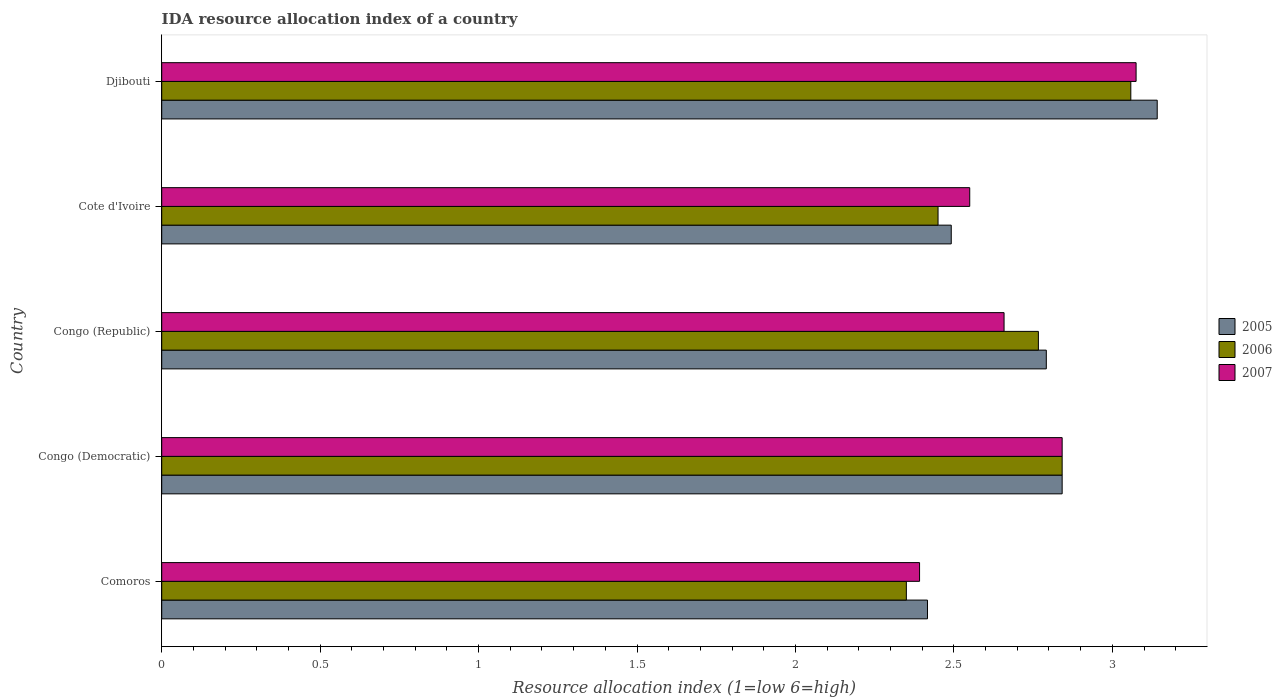How many groups of bars are there?
Your answer should be very brief. 5. Are the number of bars per tick equal to the number of legend labels?
Offer a very short reply. Yes. How many bars are there on the 3rd tick from the top?
Provide a succinct answer. 3. What is the label of the 1st group of bars from the top?
Your answer should be compact. Djibouti. What is the IDA resource allocation index in 2006 in Congo (Republic)?
Provide a succinct answer. 2.77. Across all countries, what is the maximum IDA resource allocation index in 2006?
Make the answer very short. 3.06. Across all countries, what is the minimum IDA resource allocation index in 2005?
Your response must be concise. 2.42. In which country was the IDA resource allocation index in 2007 maximum?
Your answer should be very brief. Djibouti. In which country was the IDA resource allocation index in 2007 minimum?
Give a very brief answer. Comoros. What is the total IDA resource allocation index in 2005 in the graph?
Make the answer very short. 13.68. What is the difference between the IDA resource allocation index in 2006 in Comoros and that in Congo (Democratic)?
Offer a terse response. -0.49. What is the difference between the IDA resource allocation index in 2007 in Djibouti and the IDA resource allocation index in 2005 in Cote d'Ivoire?
Make the answer very short. 0.58. What is the average IDA resource allocation index in 2005 per country?
Offer a very short reply. 2.74. What is the difference between the IDA resource allocation index in 2005 and IDA resource allocation index in 2006 in Cote d'Ivoire?
Give a very brief answer. 0.04. In how many countries, is the IDA resource allocation index in 2006 greater than 2.5 ?
Ensure brevity in your answer.  3. What is the ratio of the IDA resource allocation index in 2007 in Comoros to that in Djibouti?
Your answer should be very brief. 0.78. Is the IDA resource allocation index in 2006 in Comoros less than that in Congo (Republic)?
Provide a succinct answer. Yes. What is the difference between the highest and the second highest IDA resource allocation index in 2007?
Offer a terse response. 0.23. What is the difference between the highest and the lowest IDA resource allocation index in 2006?
Keep it short and to the point. 0.71. Is the sum of the IDA resource allocation index in 2006 in Congo (Republic) and Cote d'Ivoire greater than the maximum IDA resource allocation index in 2005 across all countries?
Provide a succinct answer. Yes. Are all the bars in the graph horizontal?
Offer a very short reply. Yes. How many countries are there in the graph?
Ensure brevity in your answer.  5. Where does the legend appear in the graph?
Keep it short and to the point. Center right. How many legend labels are there?
Offer a very short reply. 3. How are the legend labels stacked?
Your response must be concise. Vertical. What is the title of the graph?
Keep it short and to the point. IDA resource allocation index of a country. What is the label or title of the X-axis?
Give a very brief answer. Resource allocation index (1=low 6=high). What is the Resource allocation index (1=low 6=high) in 2005 in Comoros?
Your response must be concise. 2.42. What is the Resource allocation index (1=low 6=high) of 2006 in Comoros?
Give a very brief answer. 2.35. What is the Resource allocation index (1=low 6=high) of 2007 in Comoros?
Your answer should be very brief. 2.39. What is the Resource allocation index (1=low 6=high) in 2005 in Congo (Democratic)?
Your answer should be very brief. 2.84. What is the Resource allocation index (1=low 6=high) of 2006 in Congo (Democratic)?
Offer a terse response. 2.84. What is the Resource allocation index (1=low 6=high) in 2007 in Congo (Democratic)?
Give a very brief answer. 2.84. What is the Resource allocation index (1=low 6=high) in 2005 in Congo (Republic)?
Offer a terse response. 2.79. What is the Resource allocation index (1=low 6=high) in 2006 in Congo (Republic)?
Offer a terse response. 2.77. What is the Resource allocation index (1=low 6=high) in 2007 in Congo (Republic)?
Provide a short and direct response. 2.66. What is the Resource allocation index (1=low 6=high) of 2005 in Cote d'Ivoire?
Provide a short and direct response. 2.49. What is the Resource allocation index (1=low 6=high) in 2006 in Cote d'Ivoire?
Offer a terse response. 2.45. What is the Resource allocation index (1=low 6=high) in 2007 in Cote d'Ivoire?
Ensure brevity in your answer.  2.55. What is the Resource allocation index (1=low 6=high) in 2005 in Djibouti?
Provide a succinct answer. 3.14. What is the Resource allocation index (1=low 6=high) of 2006 in Djibouti?
Your response must be concise. 3.06. What is the Resource allocation index (1=low 6=high) in 2007 in Djibouti?
Provide a succinct answer. 3.08. Across all countries, what is the maximum Resource allocation index (1=low 6=high) of 2005?
Your answer should be compact. 3.14. Across all countries, what is the maximum Resource allocation index (1=low 6=high) in 2006?
Provide a short and direct response. 3.06. Across all countries, what is the maximum Resource allocation index (1=low 6=high) in 2007?
Offer a very short reply. 3.08. Across all countries, what is the minimum Resource allocation index (1=low 6=high) of 2005?
Your answer should be very brief. 2.42. Across all countries, what is the minimum Resource allocation index (1=low 6=high) of 2006?
Ensure brevity in your answer.  2.35. Across all countries, what is the minimum Resource allocation index (1=low 6=high) in 2007?
Make the answer very short. 2.39. What is the total Resource allocation index (1=low 6=high) in 2005 in the graph?
Provide a succinct answer. 13.68. What is the total Resource allocation index (1=low 6=high) in 2006 in the graph?
Your response must be concise. 13.47. What is the total Resource allocation index (1=low 6=high) in 2007 in the graph?
Your answer should be very brief. 13.52. What is the difference between the Resource allocation index (1=low 6=high) in 2005 in Comoros and that in Congo (Democratic)?
Offer a terse response. -0.42. What is the difference between the Resource allocation index (1=low 6=high) in 2006 in Comoros and that in Congo (Democratic)?
Ensure brevity in your answer.  -0.49. What is the difference between the Resource allocation index (1=low 6=high) in 2007 in Comoros and that in Congo (Democratic)?
Provide a short and direct response. -0.45. What is the difference between the Resource allocation index (1=low 6=high) in 2005 in Comoros and that in Congo (Republic)?
Keep it short and to the point. -0.38. What is the difference between the Resource allocation index (1=low 6=high) in 2006 in Comoros and that in Congo (Republic)?
Offer a very short reply. -0.42. What is the difference between the Resource allocation index (1=low 6=high) in 2007 in Comoros and that in Congo (Republic)?
Give a very brief answer. -0.27. What is the difference between the Resource allocation index (1=low 6=high) of 2005 in Comoros and that in Cote d'Ivoire?
Your answer should be compact. -0.07. What is the difference between the Resource allocation index (1=low 6=high) of 2007 in Comoros and that in Cote d'Ivoire?
Your response must be concise. -0.16. What is the difference between the Resource allocation index (1=low 6=high) of 2005 in Comoros and that in Djibouti?
Offer a very short reply. -0.72. What is the difference between the Resource allocation index (1=low 6=high) of 2006 in Comoros and that in Djibouti?
Provide a succinct answer. -0.71. What is the difference between the Resource allocation index (1=low 6=high) in 2007 in Comoros and that in Djibouti?
Provide a short and direct response. -0.68. What is the difference between the Resource allocation index (1=low 6=high) of 2006 in Congo (Democratic) and that in Congo (Republic)?
Your answer should be compact. 0.07. What is the difference between the Resource allocation index (1=low 6=high) in 2007 in Congo (Democratic) and that in Congo (Republic)?
Provide a short and direct response. 0.18. What is the difference between the Resource allocation index (1=low 6=high) of 2006 in Congo (Democratic) and that in Cote d'Ivoire?
Keep it short and to the point. 0.39. What is the difference between the Resource allocation index (1=low 6=high) of 2007 in Congo (Democratic) and that in Cote d'Ivoire?
Provide a short and direct response. 0.29. What is the difference between the Resource allocation index (1=low 6=high) in 2006 in Congo (Democratic) and that in Djibouti?
Offer a very short reply. -0.22. What is the difference between the Resource allocation index (1=low 6=high) of 2007 in Congo (Democratic) and that in Djibouti?
Provide a succinct answer. -0.23. What is the difference between the Resource allocation index (1=low 6=high) in 2006 in Congo (Republic) and that in Cote d'Ivoire?
Your response must be concise. 0.32. What is the difference between the Resource allocation index (1=low 6=high) of 2007 in Congo (Republic) and that in Cote d'Ivoire?
Give a very brief answer. 0.11. What is the difference between the Resource allocation index (1=low 6=high) in 2005 in Congo (Republic) and that in Djibouti?
Your answer should be compact. -0.35. What is the difference between the Resource allocation index (1=low 6=high) in 2006 in Congo (Republic) and that in Djibouti?
Your answer should be very brief. -0.29. What is the difference between the Resource allocation index (1=low 6=high) in 2007 in Congo (Republic) and that in Djibouti?
Offer a very short reply. -0.42. What is the difference between the Resource allocation index (1=low 6=high) of 2005 in Cote d'Ivoire and that in Djibouti?
Your response must be concise. -0.65. What is the difference between the Resource allocation index (1=low 6=high) in 2006 in Cote d'Ivoire and that in Djibouti?
Offer a very short reply. -0.61. What is the difference between the Resource allocation index (1=low 6=high) of 2007 in Cote d'Ivoire and that in Djibouti?
Offer a very short reply. -0.53. What is the difference between the Resource allocation index (1=low 6=high) of 2005 in Comoros and the Resource allocation index (1=low 6=high) of 2006 in Congo (Democratic)?
Offer a terse response. -0.42. What is the difference between the Resource allocation index (1=low 6=high) in 2005 in Comoros and the Resource allocation index (1=low 6=high) in 2007 in Congo (Democratic)?
Offer a very short reply. -0.42. What is the difference between the Resource allocation index (1=low 6=high) of 2006 in Comoros and the Resource allocation index (1=low 6=high) of 2007 in Congo (Democratic)?
Ensure brevity in your answer.  -0.49. What is the difference between the Resource allocation index (1=low 6=high) of 2005 in Comoros and the Resource allocation index (1=low 6=high) of 2006 in Congo (Republic)?
Your response must be concise. -0.35. What is the difference between the Resource allocation index (1=low 6=high) in 2005 in Comoros and the Resource allocation index (1=low 6=high) in 2007 in Congo (Republic)?
Ensure brevity in your answer.  -0.24. What is the difference between the Resource allocation index (1=low 6=high) of 2006 in Comoros and the Resource allocation index (1=low 6=high) of 2007 in Congo (Republic)?
Give a very brief answer. -0.31. What is the difference between the Resource allocation index (1=low 6=high) of 2005 in Comoros and the Resource allocation index (1=low 6=high) of 2006 in Cote d'Ivoire?
Your answer should be very brief. -0.03. What is the difference between the Resource allocation index (1=low 6=high) of 2005 in Comoros and the Resource allocation index (1=low 6=high) of 2007 in Cote d'Ivoire?
Ensure brevity in your answer.  -0.13. What is the difference between the Resource allocation index (1=low 6=high) of 2006 in Comoros and the Resource allocation index (1=low 6=high) of 2007 in Cote d'Ivoire?
Ensure brevity in your answer.  -0.2. What is the difference between the Resource allocation index (1=low 6=high) in 2005 in Comoros and the Resource allocation index (1=low 6=high) in 2006 in Djibouti?
Your answer should be very brief. -0.64. What is the difference between the Resource allocation index (1=low 6=high) in 2005 in Comoros and the Resource allocation index (1=low 6=high) in 2007 in Djibouti?
Make the answer very short. -0.66. What is the difference between the Resource allocation index (1=low 6=high) in 2006 in Comoros and the Resource allocation index (1=low 6=high) in 2007 in Djibouti?
Offer a very short reply. -0.72. What is the difference between the Resource allocation index (1=low 6=high) in 2005 in Congo (Democratic) and the Resource allocation index (1=low 6=high) in 2006 in Congo (Republic)?
Your answer should be compact. 0.07. What is the difference between the Resource allocation index (1=low 6=high) in 2005 in Congo (Democratic) and the Resource allocation index (1=low 6=high) in 2007 in Congo (Republic)?
Offer a terse response. 0.18. What is the difference between the Resource allocation index (1=low 6=high) in 2006 in Congo (Democratic) and the Resource allocation index (1=low 6=high) in 2007 in Congo (Republic)?
Offer a very short reply. 0.18. What is the difference between the Resource allocation index (1=low 6=high) of 2005 in Congo (Democratic) and the Resource allocation index (1=low 6=high) of 2006 in Cote d'Ivoire?
Provide a short and direct response. 0.39. What is the difference between the Resource allocation index (1=low 6=high) of 2005 in Congo (Democratic) and the Resource allocation index (1=low 6=high) of 2007 in Cote d'Ivoire?
Offer a terse response. 0.29. What is the difference between the Resource allocation index (1=low 6=high) of 2006 in Congo (Democratic) and the Resource allocation index (1=low 6=high) of 2007 in Cote d'Ivoire?
Your answer should be compact. 0.29. What is the difference between the Resource allocation index (1=low 6=high) in 2005 in Congo (Democratic) and the Resource allocation index (1=low 6=high) in 2006 in Djibouti?
Ensure brevity in your answer.  -0.22. What is the difference between the Resource allocation index (1=low 6=high) in 2005 in Congo (Democratic) and the Resource allocation index (1=low 6=high) in 2007 in Djibouti?
Provide a short and direct response. -0.23. What is the difference between the Resource allocation index (1=low 6=high) in 2006 in Congo (Democratic) and the Resource allocation index (1=low 6=high) in 2007 in Djibouti?
Ensure brevity in your answer.  -0.23. What is the difference between the Resource allocation index (1=low 6=high) in 2005 in Congo (Republic) and the Resource allocation index (1=low 6=high) in 2006 in Cote d'Ivoire?
Offer a very short reply. 0.34. What is the difference between the Resource allocation index (1=low 6=high) of 2005 in Congo (Republic) and the Resource allocation index (1=low 6=high) of 2007 in Cote d'Ivoire?
Offer a very short reply. 0.24. What is the difference between the Resource allocation index (1=low 6=high) in 2006 in Congo (Republic) and the Resource allocation index (1=low 6=high) in 2007 in Cote d'Ivoire?
Offer a very short reply. 0.22. What is the difference between the Resource allocation index (1=low 6=high) in 2005 in Congo (Republic) and the Resource allocation index (1=low 6=high) in 2006 in Djibouti?
Keep it short and to the point. -0.27. What is the difference between the Resource allocation index (1=low 6=high) of 2005 in Congo (Republic) and the Resource allocation index (1=low 6=high) of 2007 in Djibouti?
Provide a short and direct response. -0.28. What is the difference between the Resource allocation index (1=low 6=high) of 2006 in Congo (Republic) and the Resource allocation index (1=low 6=high) of 2007 in Djibouti?
Your answer should be very brief. -0.31. What is the difference between the Resource allocation index (1=low 6=high) in 2005 in Cote d'Ivoire and the Resource allocation index (1=low 6=high) in 2006 in Djibouti?
Keep it short and to the point. -0.57. What is the difference between the Resource allocation index (1=low 6=high) of 2005 in Cote d'Ivoire and the Resource allocation index (1=low 6=high) of 2007 in Djibouti?
Your answer should be compact. -0.58. What is the difference between the Resource allocation index (1=low 6=high) in 2006 in Cote d'Ivoire and the Resource allocation index (1=low 6=high) in 2007 in Djibouti?
Offer a terse response. -0.62. What is the average Resource allocation index (1=low 6=high) in 2005 per country?
Keep it short and to the point. 2.74. What is the average Resource allocation index (1=low 6=high) of 2006 per country?
Your answer should be compact. 2.69. What is the average Resource allocation index (1=low 6=high) of 2007 per country?
Offer a terse response. 2.7. What is the difference between the Resource allocation index (1=low 6=high) in 2005 and Resource allocation index (1=low 6=high) in 2006 in Comoros?
Keep it short and to the point. 0.07. What is the difference between the Resource allocation index (1=low 6=high) of 2005 and Resource allocation index (1=low 6=high) of 2007 in Comoros?
Your answer should be very brief. 0.03. What is the difference between the Resource allocation index (1=low 6=high) of 2006 and Resource allocation index (1=low 6=high) of 2007 in Comoros?
Offer a terse response. -0.04. What is the difference between the Resource allocation index (1=low 6=high) of 2005 and Resource allocation index (1=low 6=high) of 2006 in Congo (Democratic)?
Provide a succinct answer. 0. What is the difference between the Resource allocation index (1=low 6=high) in 2005 and Resource allocation index (1=low 6=high) in 2006 in Congo (Republic)?
Your response must be concise. 0.03. What is the difference between the Resource allocation index (1=low 6=high) in 2005 and Resource allocation index (1=low 6=high) in 2007 in Congo (Republic)?
Keep it short and to the point. 0.13. What is the difference between the Resource allocation index (1=low 6=high) in 2006 and Resource allocation index (1=low 6=high) in 2007 in Congo (Republic)?
Offer a terse response. 0.11. What is the difference between the Resource allocation index (1=low 6=high) of 2005 and Resource allocation index (1=low 6=high) of 2006 in Cote d'Ivoire?
Your response must be concise. 0.04. What is the difference between the Resource allocation index (1=low 6=high) of 2005 and Resource allocation index (1=low 6=high) of 2007 in Cote d'Ivoire?
Offer a very short reply. -0.06. What is the difference between the Resource allocation index (1=low 6=high) of 2006 and Resource allocation index (1=low 6=high) of 2007 in Cote d'Ivoire?
Offer a very short reply. -0.1. What is the difference between the Resource allocation index (1=low 6=high) of 2005 and Resource allocation index (1=low 6=high) of 2006 in Djibouti?
Provide a short and direct response. 0.08. What is the difference between the Resource allocation index (1=low 6=high) of 2005 and Resource allocation index (1=low 6=high) of 2007 in Djibouti?
Make the answer very short. 0.07. What is the difference between the Resource allocation index (1=low 6=high) in 2006 and Resource allocation index (1=low 6=high) in 2007 in Djibouti?
Provide a succinct answer. -0.02. What is the ratio of the Resource allocation index (1=low 6=high) of 2005 in Comoros to that in Congo (Democratic)?
Ensure brevity in your answer.  0.85. What is the ratio of the Resource allocation index (1=low 6=high) in 2006 in Comoros to that in Congo (Democratic)?
Your answer should be very brief. 0.83. What is the ratio of the Resource allocation index (1=low 6=high) of 2007 in Comoros to that in Congo (Democratic)?
Provide a short and direct response. 0.84. What is the ratio of the Resource allocation index (1=low 6=high) in 2005 in Comoros to that in Congo (Republic)?
Provide a succinct answer. 0.87. What is the ratio of the Resource allocation index (1=low 6=high) in 2006 in Comoros to that in Congo (Republic)?
Make the answer very short. 0.85. What is the ratio of the Resource allocation index (1=low 6=high) of 2007 in Comoros to that in Congo (Republic)?
Make the answer very short. 0.9. What is the ratio of the Resource allocation index (1=low 6=high) in 2005 in Comoros to that in Cote d'Ivoire?
Give a very brief answer. 0.97. What is the ratio of the Resource allocation index (1=low 6=high) in 2006 in Comoros to that in Cote d'Ivoire?
Your answer should be very brief. 0.96. What is the ratio of the Resource allocation index (1=low 6=high) in 2007 in Comoros to that in Cote d'Ivoire?
Your answer should be very brief. 0.94. What is the ratio of the Resource allocation index (1=low 6=high) in 2005 in Comoros to that in Djibouti?
Offer a very short reply. 0.77. What is the ratio of the Resource allocation index (1=low 6=high) of 2006 in Comoros to that in Djibouti?
Offer a terse response. 0.77. What is the ratio of the Resource allocation index (1=low 6=high) of 2007 in Comoros to that in Djibouti?
Provide a short and direct response. 0.78. What is the ratio of the Resource allocation index (1=low 6=high) of 2005 in Congo (Democratic) to that in Congo (Republic)?
Keep it short and to the point. 1.02. What is the ratio of the Resource allocation index (1=low 6=high) in 2006 in Congo (Democratic) to that in Congo (Republic)?
Give a very brief answer. 1.03. What is the ratio of the Resource allocation index (1=low 6=high) in 2007 in Congo (Democratic) to that in Congo (Republic)?
Provide a succinct answer. 1.07. What is the ratio of the Resource allocation index (1=low 6=high) of 2005 in Congo (Democratic) to that in Cote d'Ivoire?
Ensure brevity in your answer.  1.14. What is the ratio of the Resource allocation index (1=low 6=high) in 2006 in Congo (Democratic) to that in Cote d'Ivoire?
Keep it short and to the point. 1.16. What is the ratio of the Resource allocation index (1=low 6=high) in 2007 in Congo (Democratic) to that in Cote d'Ivoire?
Keep it short and to the point. 1.11. What is the ratio of the Resource allocation index (1=low 6=high) of 2005 in Congo (Democratic) to that in Djibouti?
Your answer should be very brief. 0.9. What is the ratio of the Resource allocation index (1=low 6=high) of 2006 in Congo (Democratic) to that in Djibouti?
Provide a short and direct response. 0.93. What is the ratio of the Resource allocation index (1=low 6=high) of 2007 in Congo (Democratic) to that in Djibouti?
Give a very brief answer. 0.92. What is the ratio of the Resource allocation index (1=low 6=high) of 2005 in Congo (Republic) to that in Cote d'Ivoire?
Offer a very short reply. 1.12. What is the ratio of the Resource allocation index (1=low 6=high) in 2006 in Congo (Republic) to that in Cote d'Ivoire?
Provide a short and direct response. 1.13. What is the ratio of the Resource allocation index (1=low 6=high) in 2007 in Congo (Republic) to that in Cote d'Ivoire?
Offer a very short reply. 1.04. What is the ratio of the Resource allocation index (1=low 6=high) in 2005 in Congo (Republic) to that in Djibouti?
Keep it short and to the point. 0.89. What is the ratio of the Resource allocation index (1=low 6=high) of 2006 in Congo (Republic) to that in Djibouti?
Your answer should be very brief. 0.9. What is the ratio of the Resource allocation index (1=low 6=high) in 2007 in Congo (Republic) to that in Djibouti?
Provide a short and direct response. 0.86. What is the ratio of the Resource allocation index (1=low 6=high) of 2005 in Cote d'Ivoire to that in Djibouti?
Ensure brevity in your answer.  0.79. What is the ratio of the Resource allocation index (1=low 6=high) of 2006 in Cote d'Ivoire to that in Djibouti?
Your answer should be compact. 0.8. What is the ratio of the Resource allocation index (1=low 6=high) of 2007 in Cote d'Ivoire to that in Djibouti?
Keep it short and to the point. 0.83. What is the difference between the highest and the second highest Resource allocation index (1=low 6=high) in 2006?
Provide a succinct answer. 0.22. What is the difference between the highest and the second highest Resource allocation index (1=low 6=high) of 2007?
Offer a very short reply. 0.23. What is the difference between the highest and the lowest Resource allocation index (1=low 6=high) in 2005?
Offer a terse response. 0.72. What is the difference between the highest and the lowest Resource allocation index (1=low 6=high) of 2006?
Your answer should be very brief. 0.71. What is the difference between the highest and the lowest Resource allocation index (1=low 6=high) in 2007?
Keep it short and to the point. 0.68. 